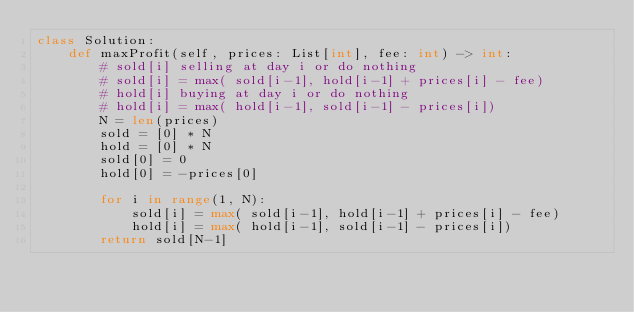Convert code to text. <code><loc_0><loc_0><loc_500><loc_500><_Python_>class Solution:
    def maxProfit(self, prices: List[int], fee: int) -> int:
        # sold[i] selling at day i or do nothing
        # sold[i] = max( sold[i-1], hold[i-1] + prices[i] - fee)
        # hold[i] buying at day i or do nothing
        # hold[i] = max( hold[i-1], sold[i-1] - prices[i])
        N = len(prices)
        sold = [0] * N
        hold = [0] * N
        sold[0] = 0
        hold[0] = -prices[0]
        
        for i in range(1, N):
            sold[i] = max( sold[i-1], hold[i-1] + prices[i] - fee)
            hold[i] = max( hold[i-1], sold[i-1] - prices[i])
        return sold[N-1]
</code> 